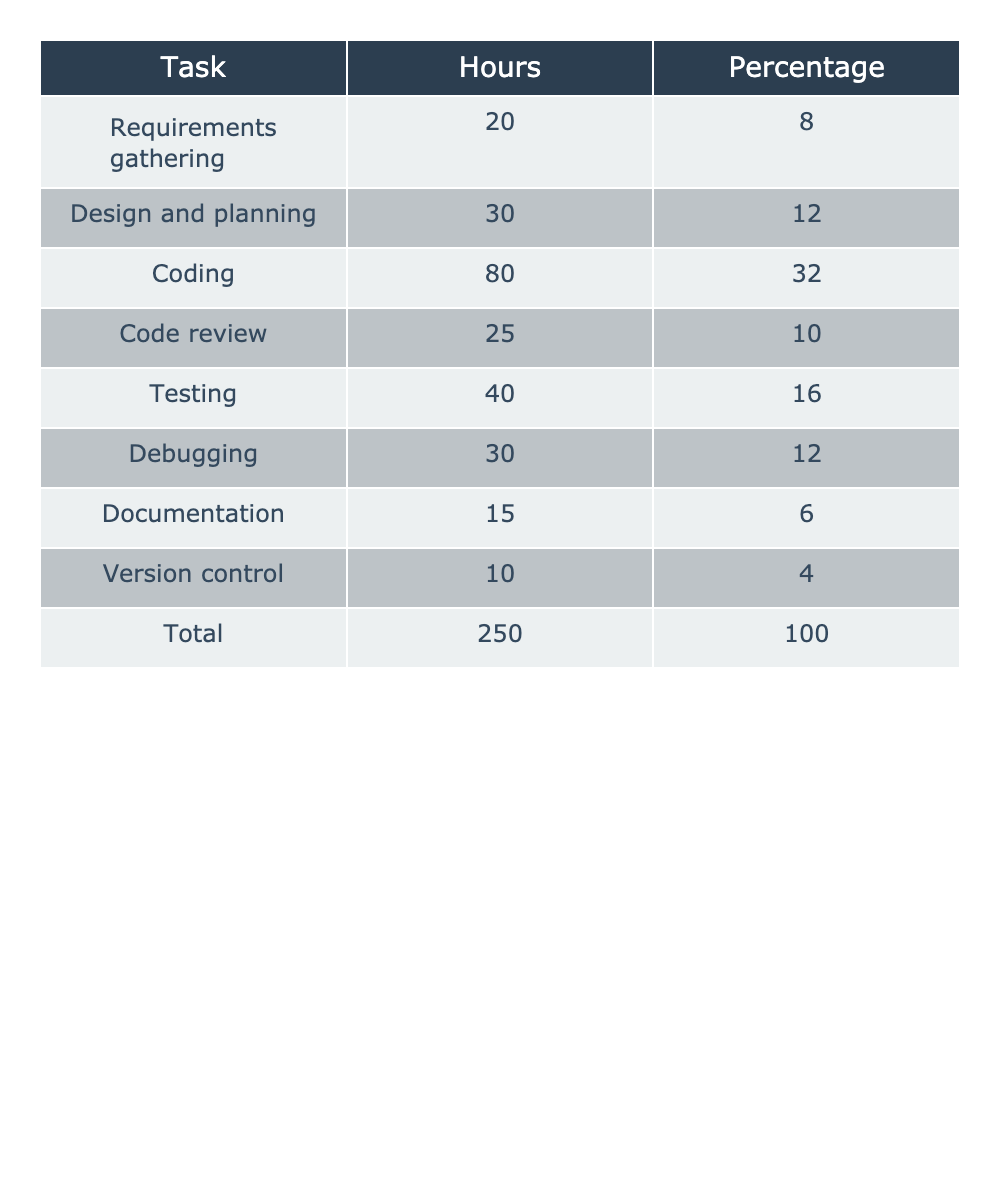What is the total time spent on coding? The table indicates that the hours spent on coding is listed as 80. Thus, the total time spent on coding is directly taken from the table.
Answer: 80 What percentage of the total time is spent on documentation? According to the table, documentation takes up 6% of the total time. This percentage can be found by referring to the relevant row.
Answer: 6% How much more time is spent on testing than on debugging? The time spent on testing is 40 hours, while debugging takes 30 hours. The difference is calculated as 40 - 30 = 10 hours.
Answer: 10 Which task takes the most time, and what is its hour count? The coding task, with 80 hours, takes the most time. By scanning the hours column, we can find that this is the highest value.
Answer: Coding, 80 hours What is the combined percentage of time spent on requirements gathering and design and planning? Requirements gathering is 8% and design and planning is 12%. Adding these together gives 8 + 12 = 20%.
Answer: 20% If we add the hours spent on code review and testing, what is the total? Code review takes 25 hours and testing takes 40 hours. By summing these amounts, we get 25 + 40 = 65 hours.
Answer: 65 Is debugging time greater than the time spent on documentation? Debugging takes 30 hours, while documentation takes 15 hours. Since 30 > 15, the statement is true.
Answer: Yes What is the average time spent on all tasks? The total time for all tasks is 250 hours, and there are 8 tasks. By dividing the total by the number of tasks, 250/8 = 31.25 hours.
Answer: 31.25 How much percentage of time is spent on coding and testing combined? The percentage for coding is 32%, and for testing, it is 16%. Summing these percentages gives 32 + 16 = 48%.
Answer: 48% If we were to exclude the lowest time task, what would be the new total percentage for the remaining tasks? The lowest time task is version control at 4%. Excluding it means we consider the rest which sums to 100 - 4 = 96%.
Answer: 96% 